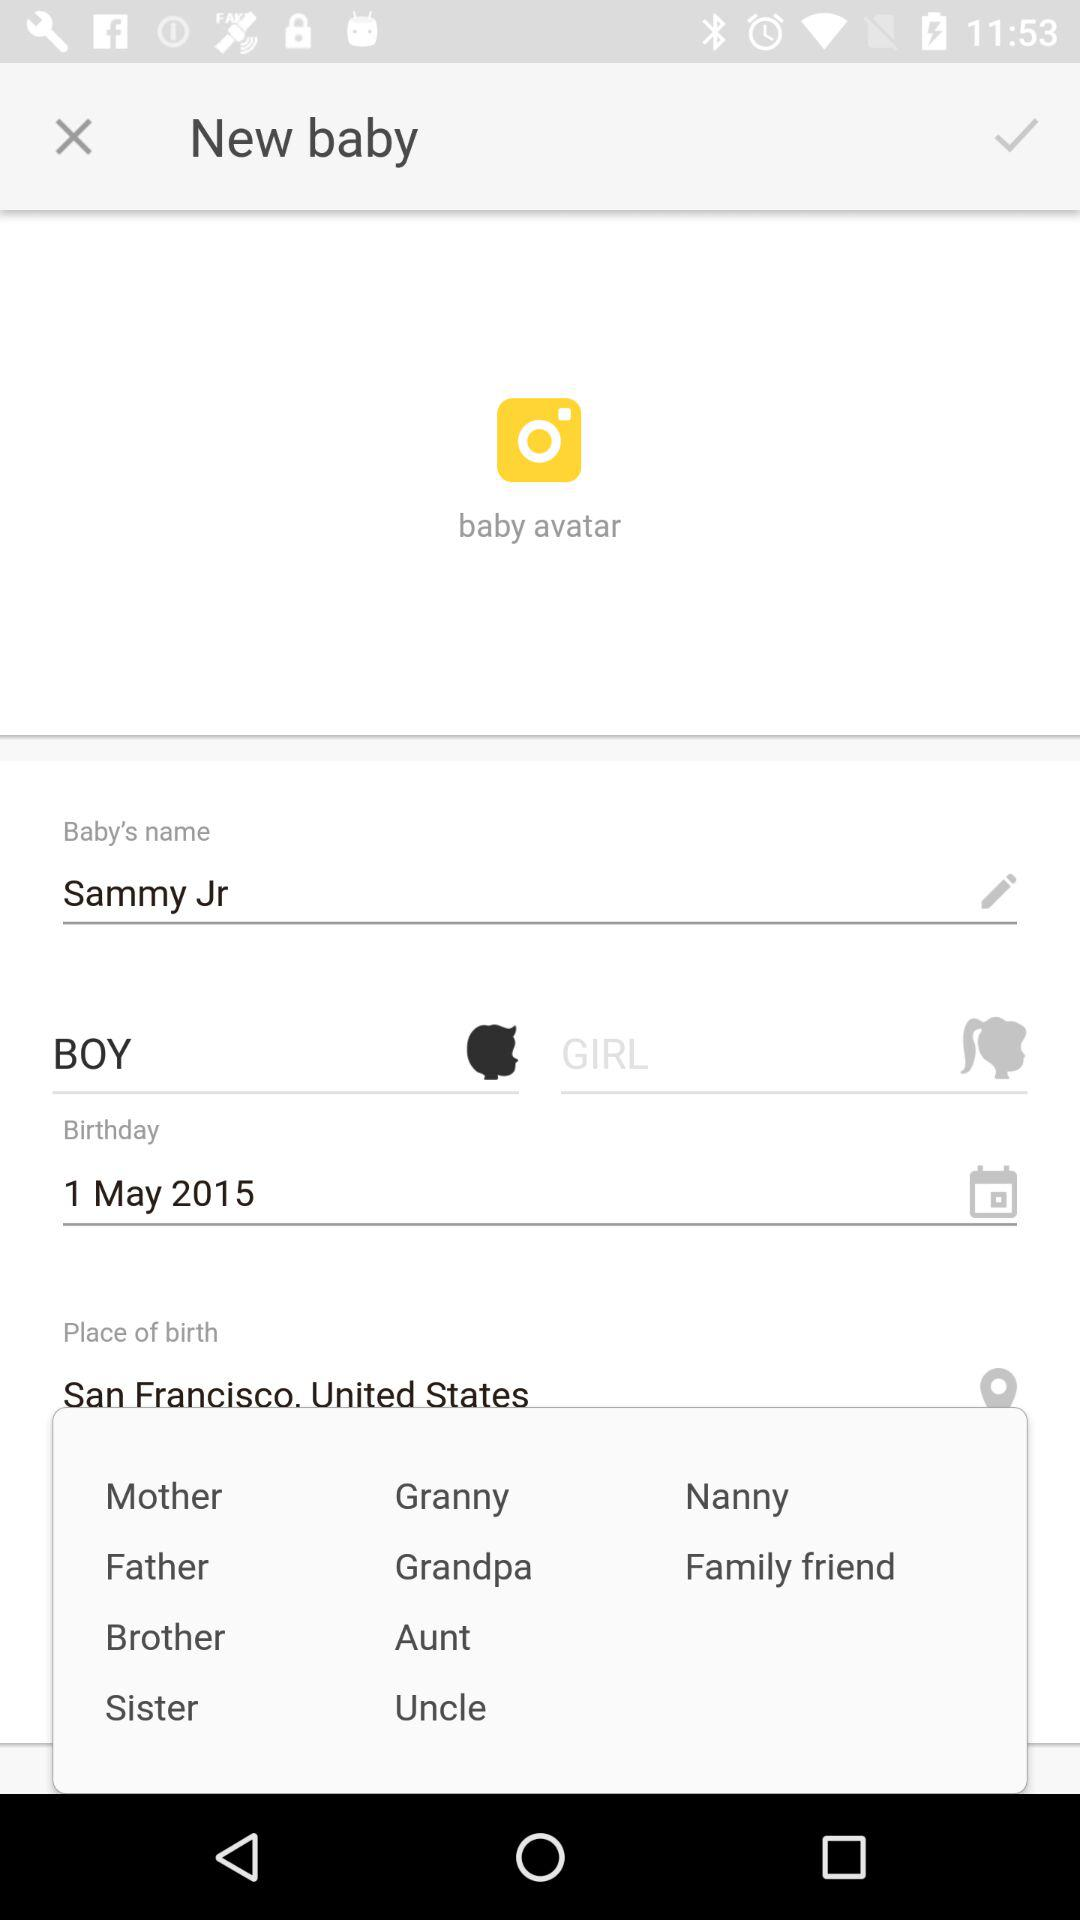How much does the new baby weigh?
When the provided information is insufficient, respond with <no answer>. <no answer> 